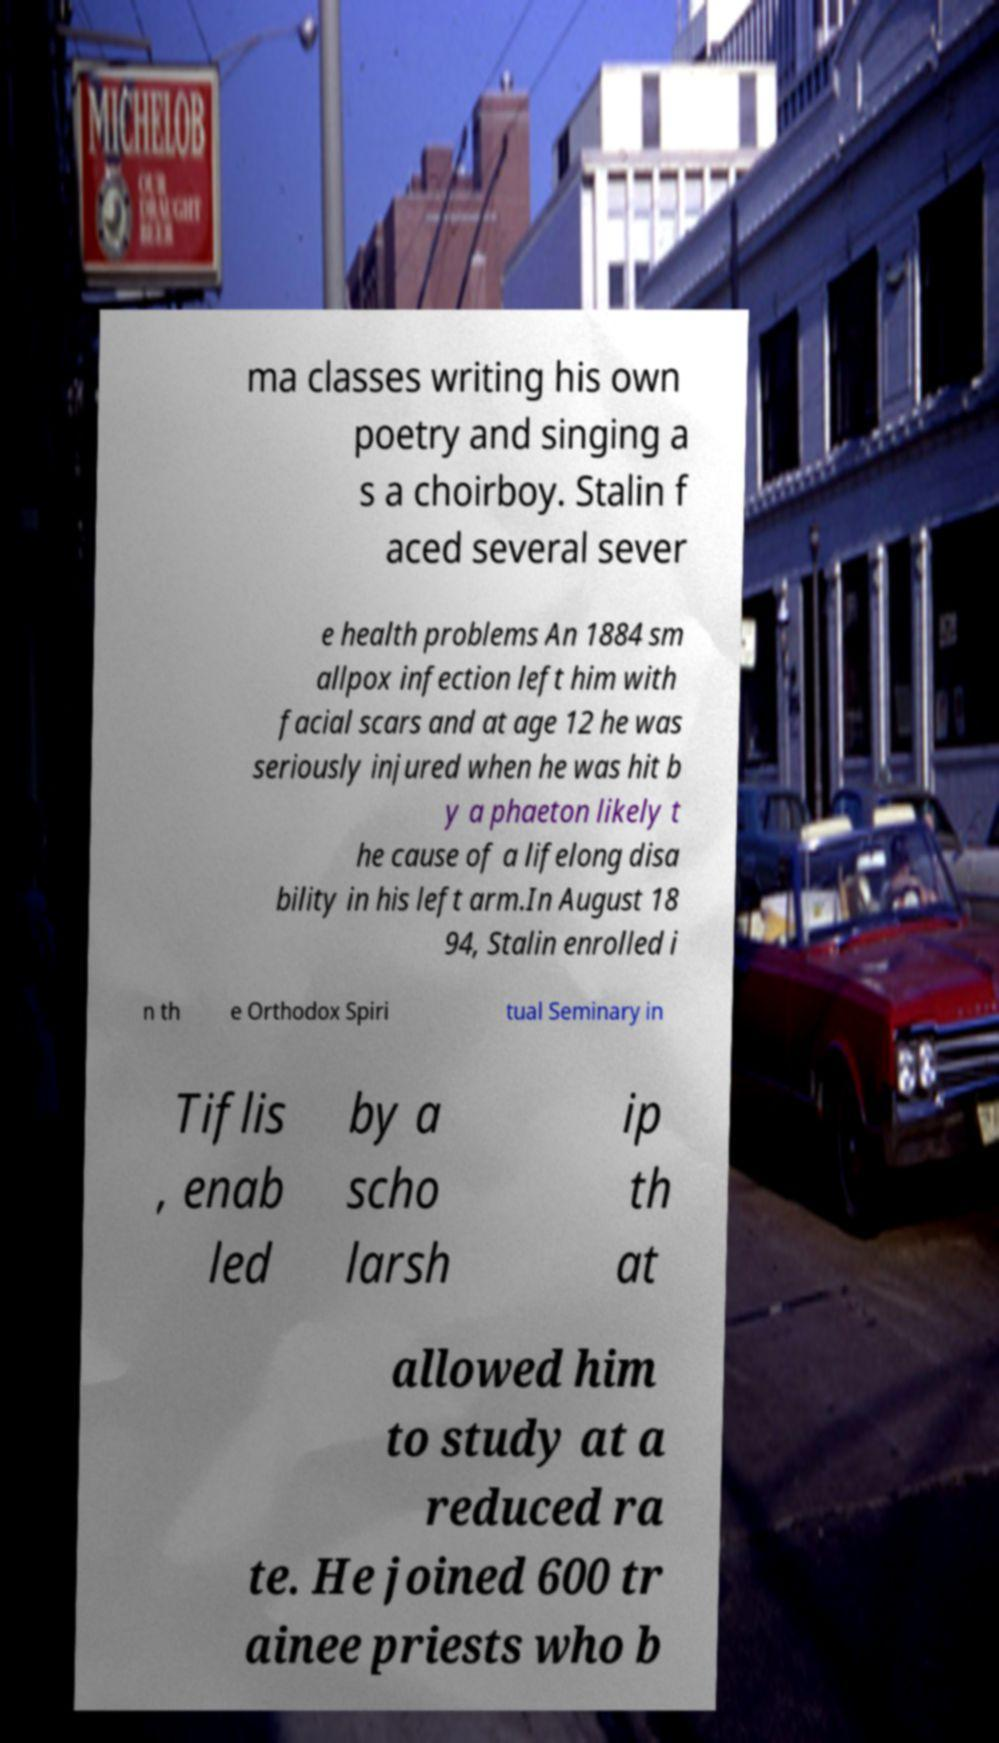Can you accurately transcribe the text from the provided image for me? ma classes writing his own poetry and singing a s a choirboy. Stalin f aced several sever e health problems An 1884 sm allpox infection left him with facial scars and at age 12 he was seriously injured when he was hit b y a phaeton likely t he cause of a lifelong disa bility in his left arm.In August 18 94, Stalin enrolled i n th e Orthodox Spiri tual Seminary in Tiflis , enab led by a scho larsh ip th at allowed him to study at a reduced ra te. He joined 600 tr ainee priests who b 